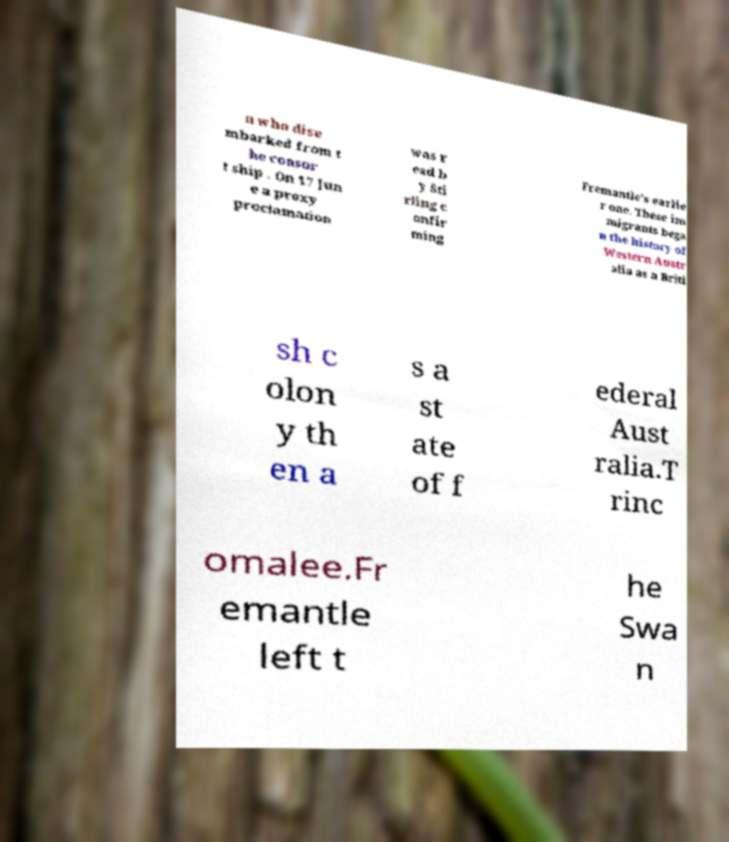For documentation purposes, I need the text within this image transcribed. Could you provide that? n who dise mbarked from t he consor t ship . On 17 Jun e a proxy proclamation was r ead b y Sti rling c onfir ming Fremantle's earlie r one. These im migrants bega n the history of Western Austr alia as a Briti sh c olon y th en a s a st ate of f ederal Aust ralia.T rinc omalee.Fr emantle left t he Swa n 